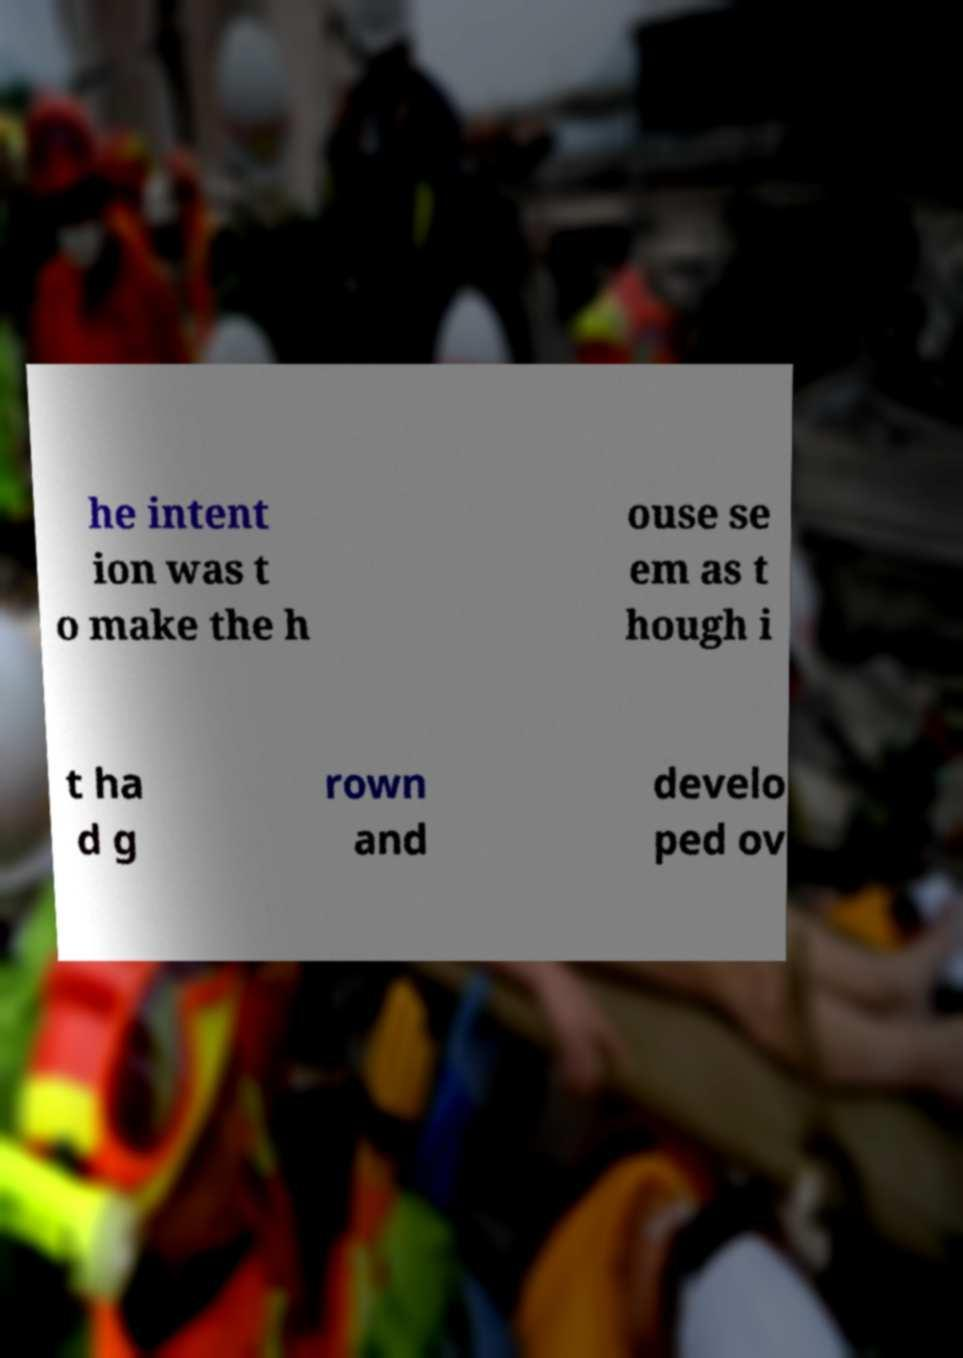Could you assist in decoding the text presented in this image and type it out clearly? he intent ion was t o make the h ouse se em as t hough i t ha d g rown and develo ped ov 